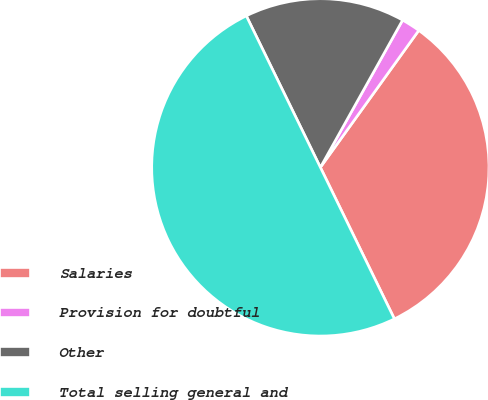Convert chart to OTSL. <chart><loc_0><loc_0><loc_500><loc_500><pie_chart><fcel>Salaries<fcel>Provision for doubtful<fcel>Other<fcel>Total selling general and<nl><fcel>32.85%<fcel>1.81%<fcel>15.34%<fcel>50.0%<nl></chart> 